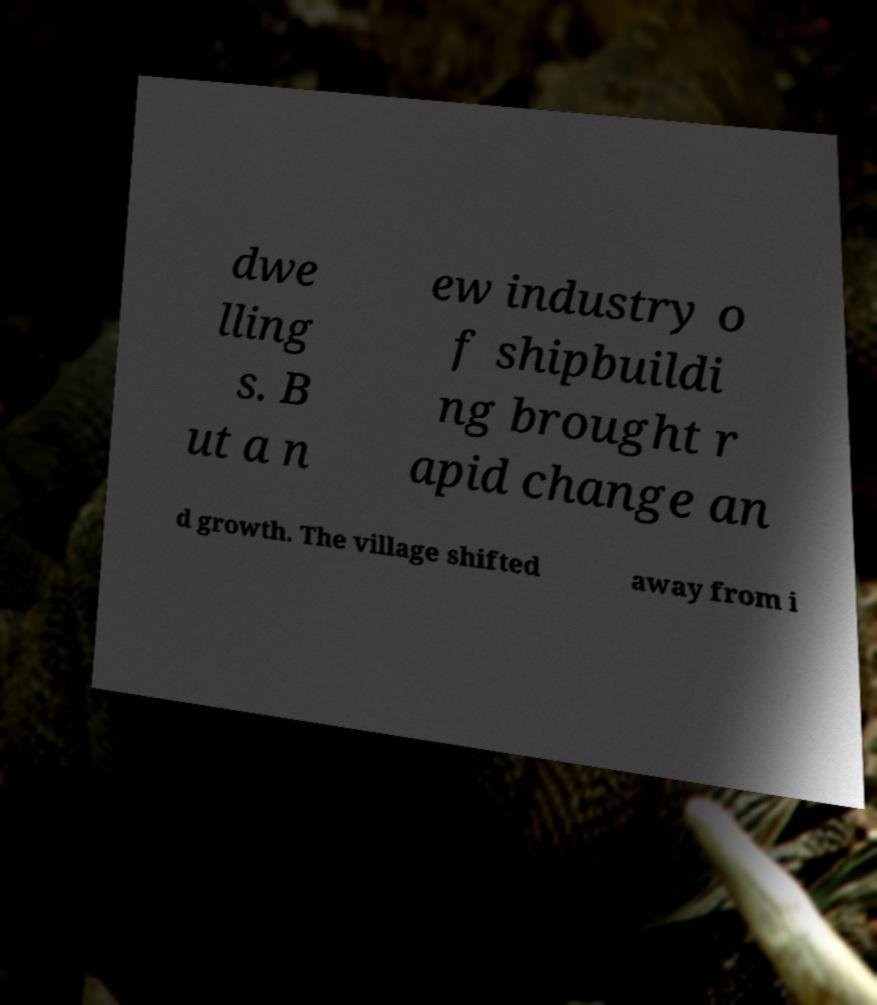Could you assist in decoding the text presented in this image and type it out clearly? dwe lling s. B ut a n ew industry o f shipbuildi ng brought r apid change an d growth. The village shifted away from i 